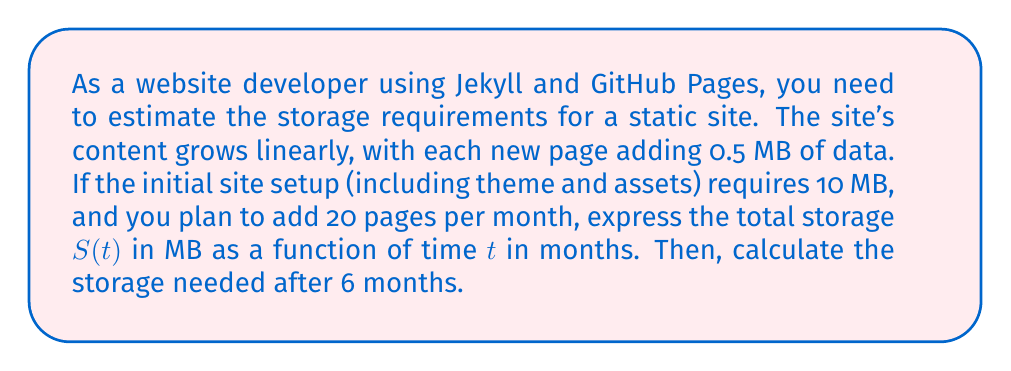What is the answer to this math problem? Let's approach this step-by-step:

1) First, we need to identify the components of our linear function:
   - Initial value (y-intercept): 10 MB (initial site setup)
   - Rate of change (slope): 0.5 MB/page × 20 pages/month = 10 MB/month

2) The general form of a linear function is:
   $$S(t) = mt + b$$
   where $m$ is the slope and $b$ is the y-intercept.

3) Substituting our values:
   $$S(t) = 10t + 10$$
   where $S(t)$ is the storage in MB and $t$ is the time in months.

4) To calculate the storage needed after 6 months, we substitute $t = 6$ into our function:
   $$S(6) = 10(6) + 10$$
   $$S(6) = 60 + 10 = 70$$

Therefore, after 6 months, the site will require 70 MB of storage.
Answer: $S(t) = 10t + 10$; 70 MB after 6 months 